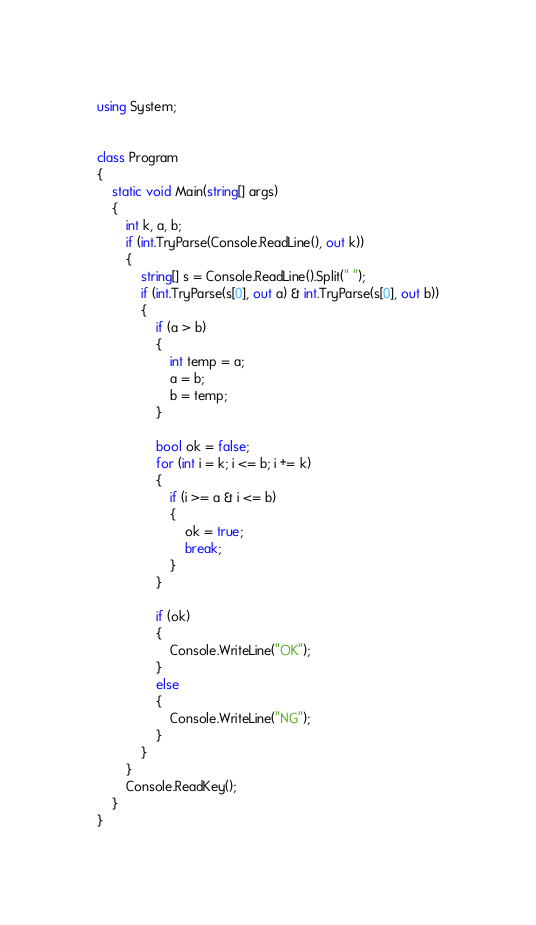Convert code to text. <code><loc_0><loc_0><loc_500><loc_500><_C#_>using System;


class Program
{
    static void Main(string[] args)
    {
        int k, a, b;
        if (int.TryParse(Console.ReadLine(), out k))
        {
            string[] s = Console.ReadLine().Split(" ");
            if (int.TryParse(s[0], out a) & int.TryParse(s[0], out b))
            {
                if (a > b)
                {
                    int temp = a;
                    a = b;
                    b = temp;
                }

                bool ok = false;
                for (int i = k; i <= b; i += k)
                {
                    if (i >= a & i <= b)
                    {
                        ok = true;
                        break;
                    }
                }

                if (ok)
                {
                    Console.WriteLine("OK");
                }
                else
                {
                    Console.WriteLine("NG");
                }
            }
        }
        Console.ReadKey();
    }
}
</code> 